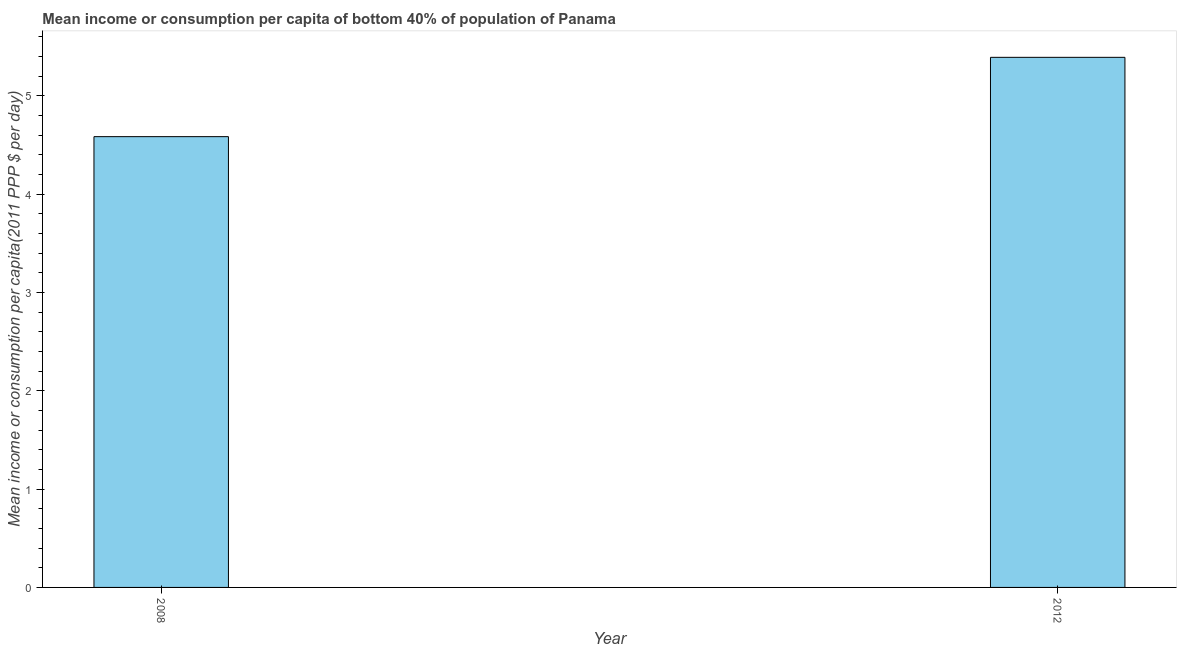Does the graph contain grids?
Make the answer very short. No. What is the title of the graph?
Your answer should be very brief. Mean income or consumption per capita of bottom 40% of population of Panama. What is the label or title of the X-axis?
Ensure brevity in your answer.  Year. What is the label or title of the Y-axis?
Offer a terse response. Mean income or consumption per capita(2011 PPP $ per day). What is the mean income or consumption in 2008?
Offer a terse response. 4.58. Across all years, what is the maximum mean income or consumption?
Ensure brevity in your answer.  5.39. Across all years, what is the minimum mean income or consumption?
Your answer should be very brief. 4.58. In which year was the mean income or consumption maximum?
Provide a short and direct response. 2012. What is the sum of the mean income or consumption?
Offer a very short reply. 9.97. What is the difference between the mean income or consumption in 2008 and 2012?
Keep it short and to the point. -0.81. What is the average mean income or consumption per year?
Offer a very short reply. 4.99. What is the median mean income or consumption?
Your answer should be very brief. 4.99. What is the ratio of the mean income or consumption in 2008 to that in 2012?
Provide a succinct answer. 0.85. Is the mean income or consumption in 2008 less than that in 2012?
Keep it short and to the point. Yes. Are the values on the major ticks of Y-axis written in scientific E-notation?
Your answer should be compact. No. What is the Mean income or consumption per capita(2011 PPP $ per day) of 2008?
Offer a terse response. 4.58. What is the Mean income or consumption per capita(2011 PPP $ per day) in 2012?
Ensure brevity in your answer.  5.39. What is the difference between the Mean income or consumption per capita(2011 PPP $ per day) in 2008 and 2012?
Provide a short and direct response. -0.81. What is the ratio of the Mean income or consumption per capita(2011 PPP $ per day) in 2008 to that in 2012?
Ensure brevity in your answer.  0.85. 